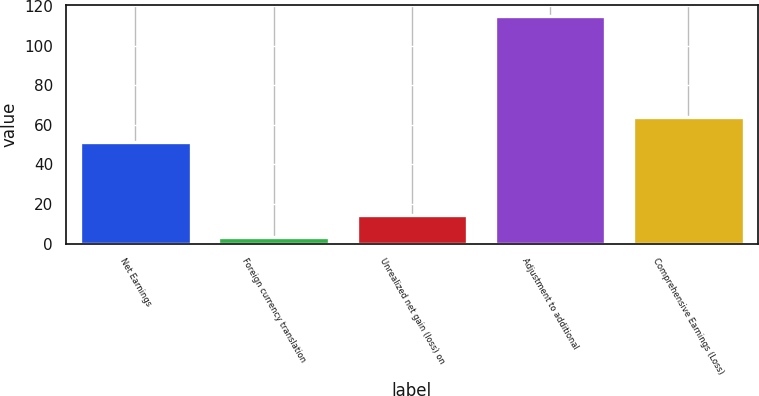<chart> <loc_0><loc_0><loc_500><loc_500><bar_chart><fcel>Net Earnings<fcel>Foreign currency translation<fcel>Unrealized net gain (loss) on<fcel>Adjustment to additional<fcel>Comprehensive Earnings (Loss)<nl><fcel>51.3<fcel>3.1<fcel>14.26<fcel>114.7<fcel>63.7<nl></chart> 